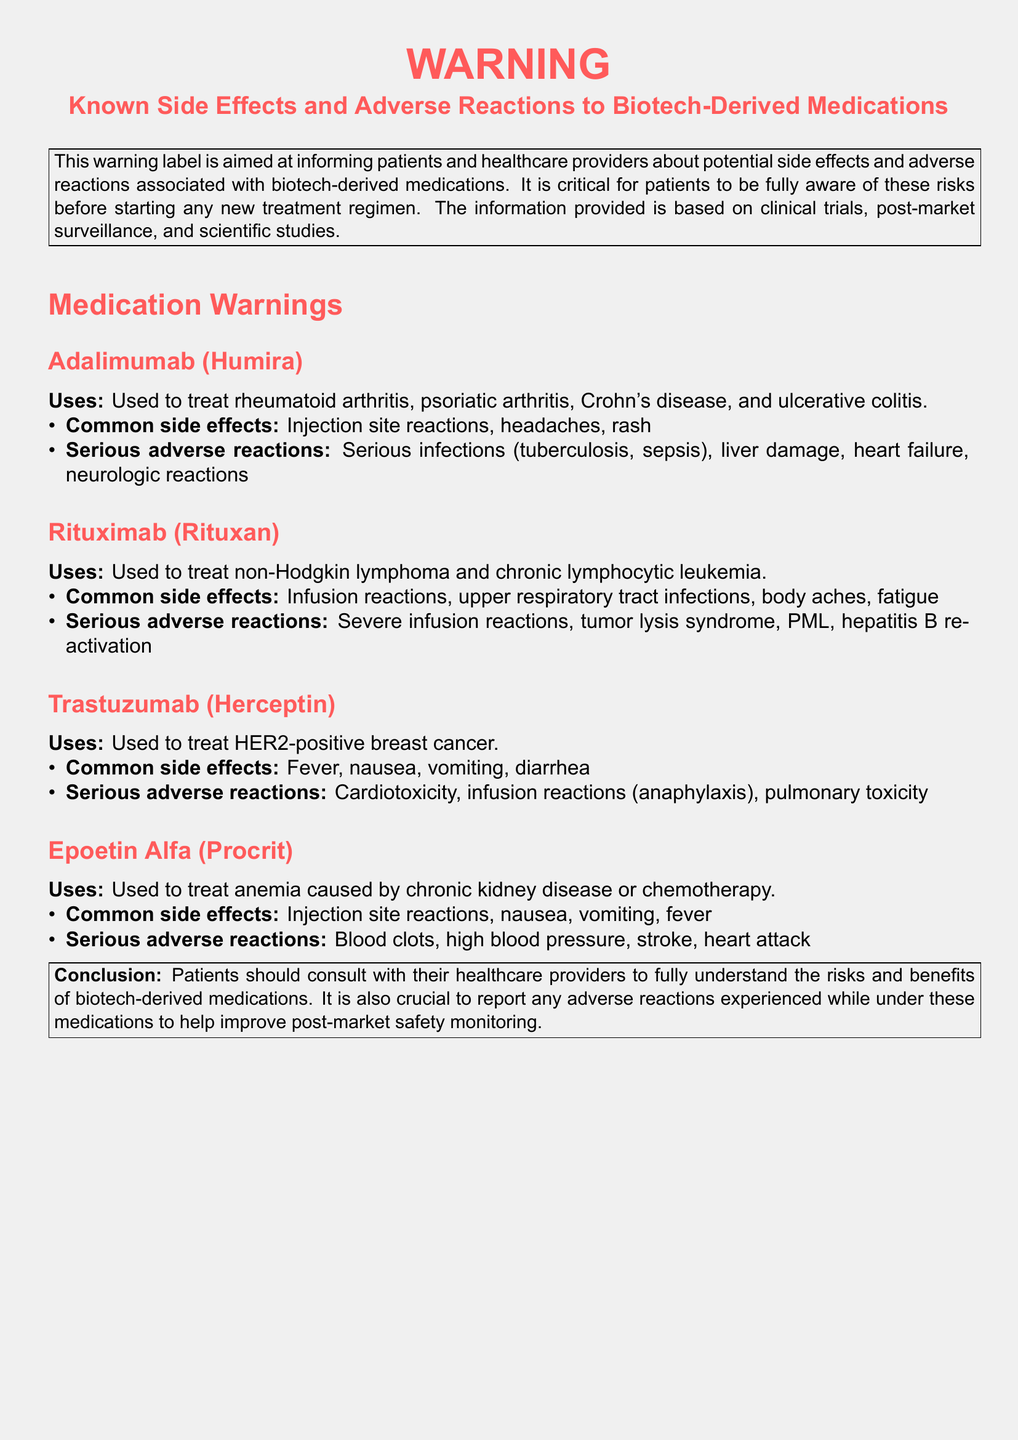What is the primary purpose of the warning label? The primary purpose of the warning label is to inform patients and healthcare providers about potential side effects and adverse reactions associated with biotech-derived medications.
Answer: Inform patients and healthcare providers about potential side effects and adverse reactions What are the common side effects of Adalimumab? Common side effects of Adalimumab include injection site reactions, headaches, and rash.
Answer: Injection site reactions, headaches, rash What serious adverse reactions are associated with Rituximab? The serious adverse reactions associated with Rituximab include severe infusion reactions, tumor lysis syndrome, PML, and hepatitis B reactivation.
Answer: Severe infusion reactions, tumor lysis syndrome, PML, hepatitis B reactivation How many medication warnings are listed in the document? The document lists a total of four medication warnings.
Answer: Four What does the conclusion of the warning label emphasize? The conclusion emphasizes that patients should consult with their healthcare providers to understand the risks and benefits of biotech-derived medications.
Answer: Consult with healthcare providers to understand risks and benefits What serious adverse reaction is specifically mentioned for Trastuzumab? The serious adverse reaction specifically mentioned for Trastuzumab is cardiotoxicity.
Answer: Cardiotoxicity What type of infections are common side effects of Rituximab? Common side effects of Rituximab include upper respiratory tract infections.
Answer: Upper respiratory tract infections Which medication is used to treat anemia? Epoetin Alfa (Procrit) is used to treat anemia caused by chronic kidney disease or chemotherapy.
Answer: Epoetin Alfa (Procrit) 